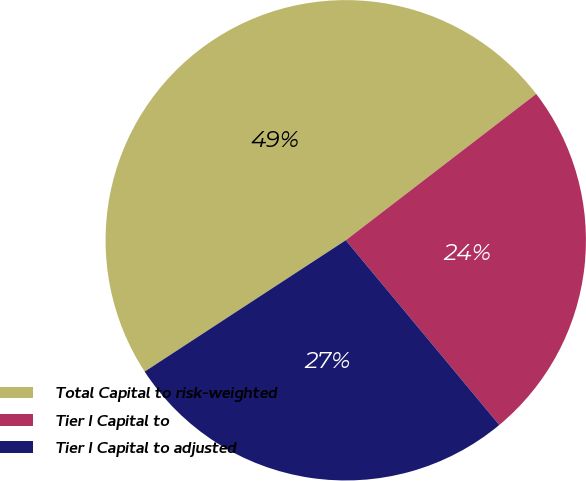Convert chart. <chart><loc_0><loc_0><loc_500><loc_500><pie_chart><fcel>Total Capital to risk-weighted<fcel>Tier I Capital to<fcel>Tier I Capital to adjusted<nl><fcel>48.78%<fcel>24.39%<fcel>26.83%<nl></chart> 